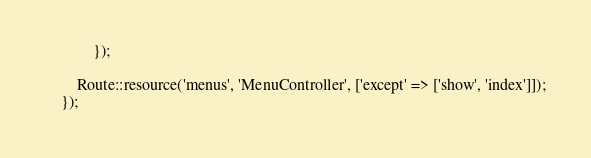<code> <loc_0><loc_0><loc_500><loc_500><_PHP_>            });

        Route::resource('menus', 'MenuController', ['except' => ['show', 'index']]);
    });
</code> 